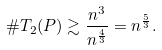Convert formula to latex. <formula><loc_0><loc_0><loc_500><loc_500>\# T _ { 2 } ( P ) \gtrsim \frac { n ^ { 3 } } { n ^ { \frac { 4 } { 3 } } } = n ^ { \frac { 5 } { 3 } } .</formula> 